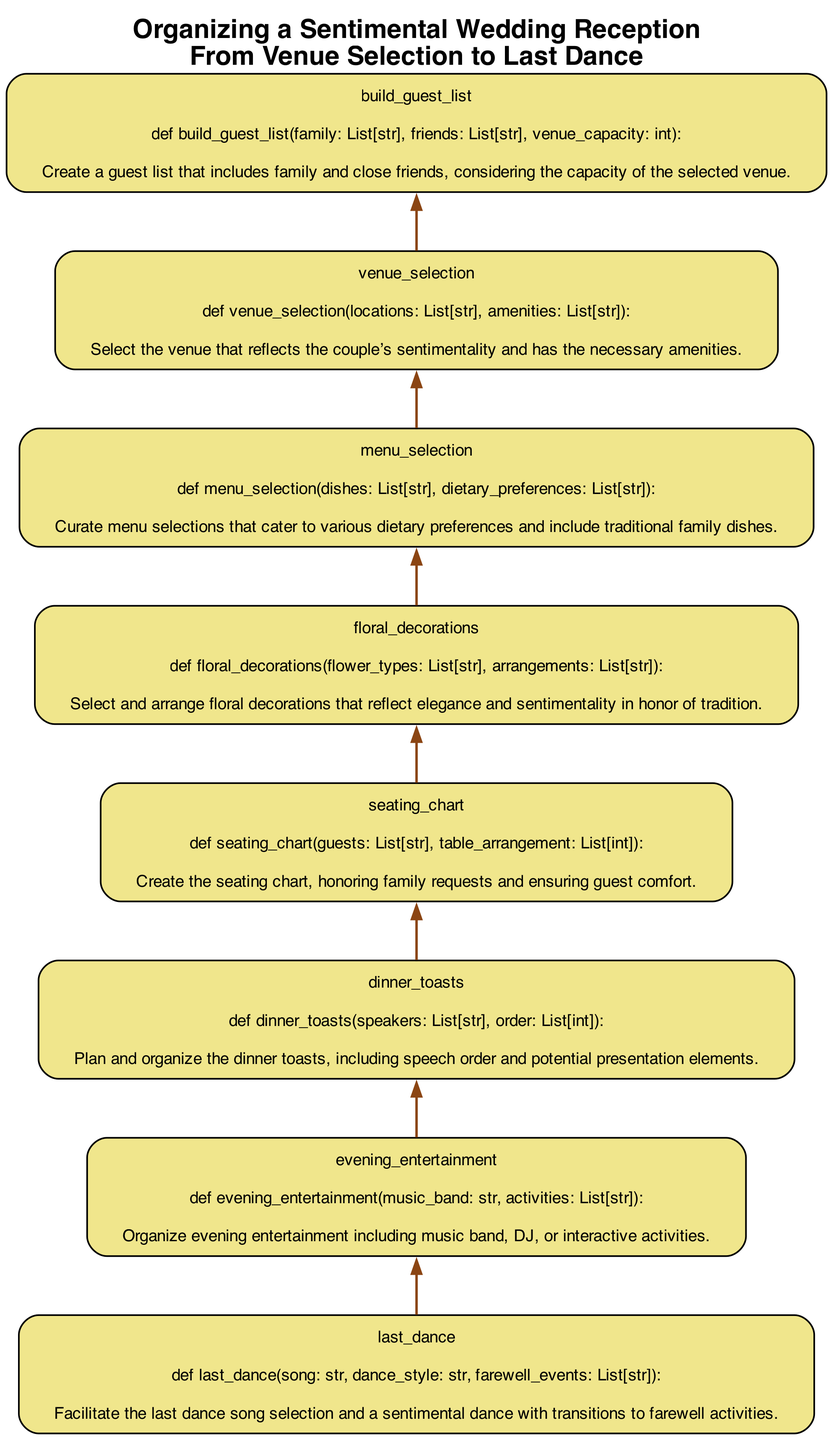What's the first step in organizing the wedding reception? The first step, as depicted at the bottom of the flowchart, is the venue selection. This is indicated by the element labeled "venue_selection," which is the first node encountered when following the flow from bottom to up.
Answer: venue selection How many elements are listed in the diagram? To find the total number of elements, one can count each node present in the flowchart. There are 8 distinct nodes listed from "last_dance" to "venue_selection." Therefore, the total count is 8.
Answer: 8 Which function focuses on creating a comfortable seating arrangement? The function that pertains to seating arrangements is labeled "seating_chart." It specifically mentions the creation of a seating chart, emphasizing the importance of accommodating family requests and guest comfort, which is noted in its description.
Answer: seating_chart What is the role of floral decorations in the wedding reception? Upon reviewing the diagram, it can be seen that the floral_decorations element aims to select and arrange blossoms that convey elegance and sentimentality, honoring tradition. Thus, the main focus is to ensure the floral designs resonate with the wedding's overall sentiment.
Answer: select and arrange floral decorations Which function is at the very top of the flowchart? By observing the diagram from the bottom to the top, the last element encountered is "last_dance." This function is positioned at the topmost part of the flowchart, indicating it is the final step in the process being illustrated.
Answer: last_dance What comes directly before the last dance in the process? In the flowchart structure, "evening_entertainment" directly precedes "last_dance." By tracing the flow upwards, one can see that these two functions are connected sequentially, reflecting the order of activities at the wedding reception.
Answer: evening_entertainment How does the dinner toasts function relate to the overall reception flow? "Dinner_toasts" is a crucial part of the reception timeline, appearing between seating arrangements and evening entertainment. The logical flow suggests that after setting the seating chart and before arranging evening entertainment, the dinner toasts are conducted, serving as a meaningful transition within the evening’s events.
Answer: transition within the evening's events What is the primary consideration in menu selection? According to the description associated with the "menu_selection" element, the primary consideration is to curate menu selections that cater to various dietary preferences while also including traditional family dishes, highlighting the importance of inclusivity and tradition.
Answer: dietary preferences and traditional family dishes 